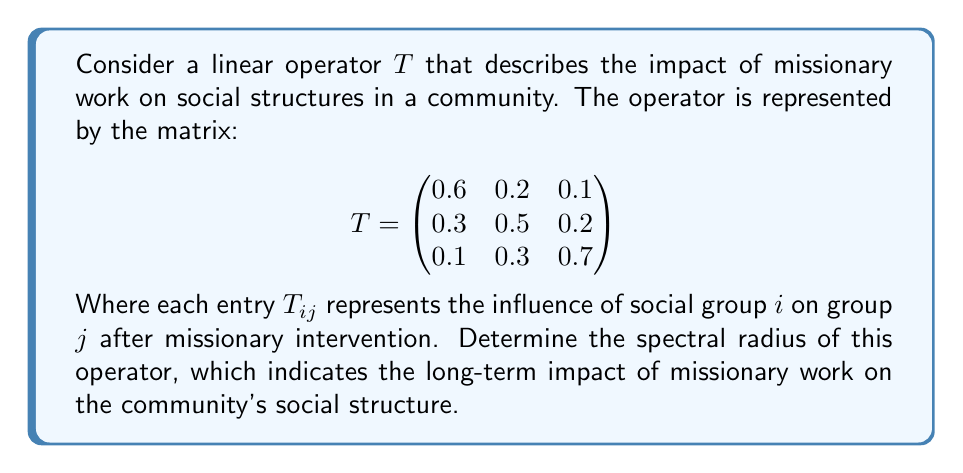Can you solve this math problem? To find the spectral radius of the linear operator $T$, we need to follow these steps:

1) First, we need to find the eigenvalues of $T$. The characteristic equation is:

   $$\det(T - \lambda I) = 0$$

2) Expanding this, we get:

   $$(0.6 - \lambda)(0.5 - \lambda)(0.7 - \lambda) - 0.2 \cdot 0.2 \cdot 0.1 - 0.1 \cdot 0.3 \cdot 0.3$$
   $$- (0.1 \cdot 0.2 \cdot 0.3 + 0.1 \cdot 0.3 \cdot 0.5 + 0.6 \cdot 0.2 \cdot 0.3) = 0$$

3) Simplifying:

   $$-\lambda^3 + 1.8\lambda^2 - 0.99\lambda + 0.168 = 0$$

4) This cubic equation can be solved using numerical methods. The roots (eigenvalues) are approximately:

   $$\lambda_1 \approx 1.0392, \lambda_2 \approx 0.4804, \lambda_3 \approx 0.2804$$

5) The spectral radius $\rho(T)$ is the maximum absolute value of the eigenvalues:

   $$\rho(T) = \max\{|\lambda_1|, |\lambda_2|, |\lambda_3|\} = |\lambda_1| \approx 1.0392$$

This value being slightly greater than 1 suggests that the missionary work has a slowly increasing long-term impact on the community's social structure.
Answer: $\rho(T) \approx 1.0392$ 